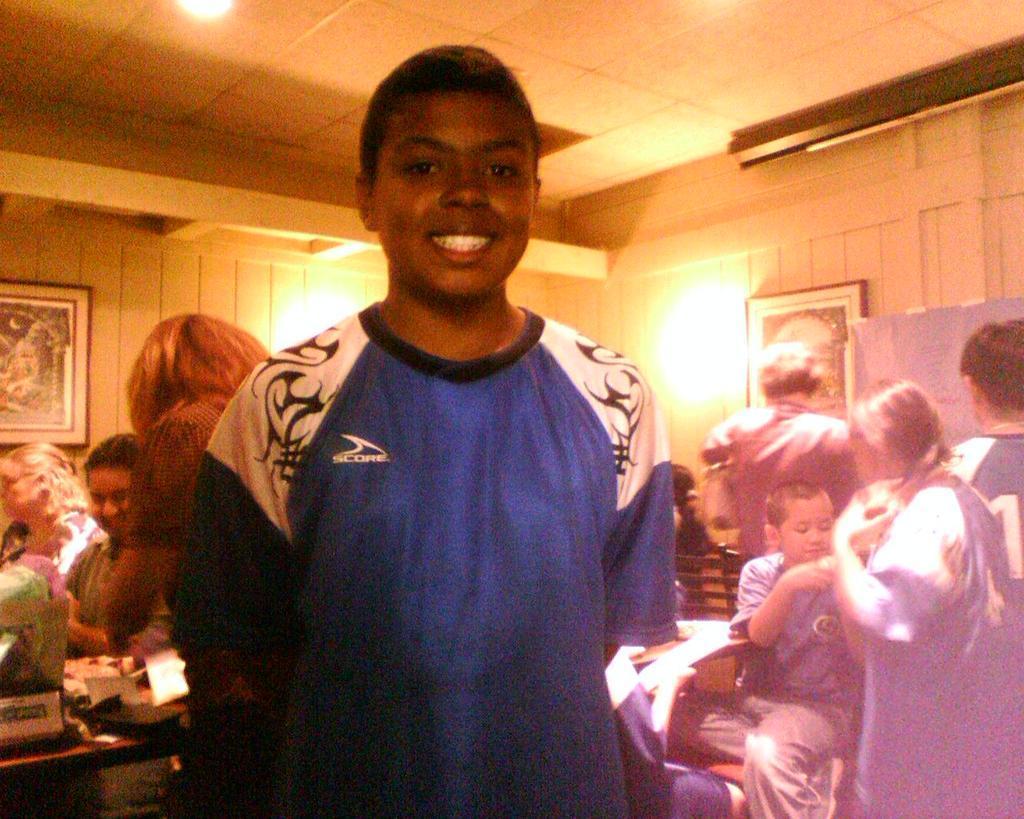In one or two sentences, can you explain what this image depicts? In this picture I can see there are some people standing and sitting. In the backdrop there is a wall and there is a photo frame and there is a lamp on the wall. 